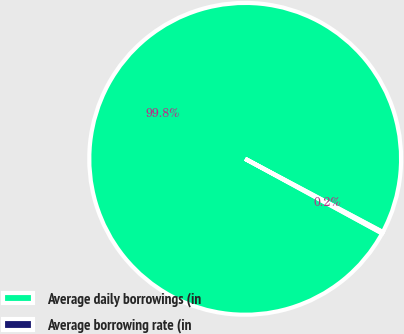Convert chart. <chart><loc_0><loc_0><loc_500><loc_500><pie_chart><fcel>Average daily borrowings (in<fcel>Average borrowing rate (in<nl><fcel>99.84%<fcel>0.16%<nl></chart> 